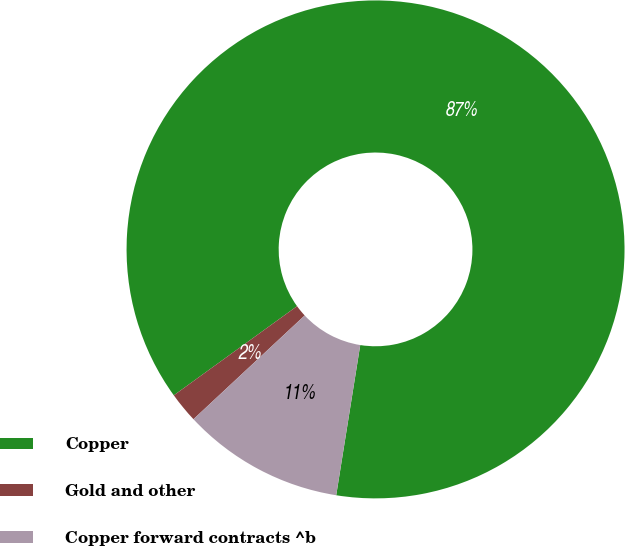<chart> <loc_0><loc_0><loc_500><loc_500><pie_chart><fcel>Copper<fcel>Gold and other<fcel>Copper forward contracts ^b<nl><fcel>87.5%<fcel>1.98%<fcel>10.53%<nl></chart> 